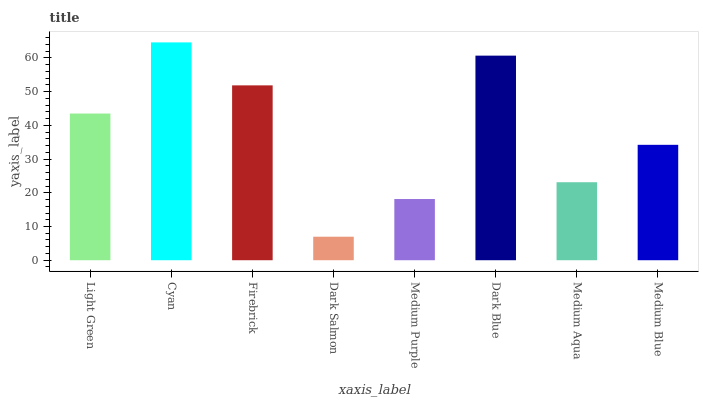Is Dark Salmon the minimum?
Answer yes or no. Yes. Is Cyan the maximum?
Answer yes or no. Yes. Is Firebrick the minimum?
Answer yes or no. No. Is Firebrick the maximum?
Answer yes or no. No. Is Cyan greater than Firebrick?
Answer yes or no. Yes. Is Firebrick less than Cyan?
Answer yes or no. Yes. Is Firebrick greater than Cyan?
Answer yes or no. No. Is Cyan less than Firebrick?
Answer yes or no. No. Is Light Green the high median?
Answer yes or no. Yes. Is Medium Blue the low median?
Answer yes or no. Yes. Is Dark Blue the high median?
Answer yes or no. No. Is Dark Blue the low median?
Answer yes or no. No. 